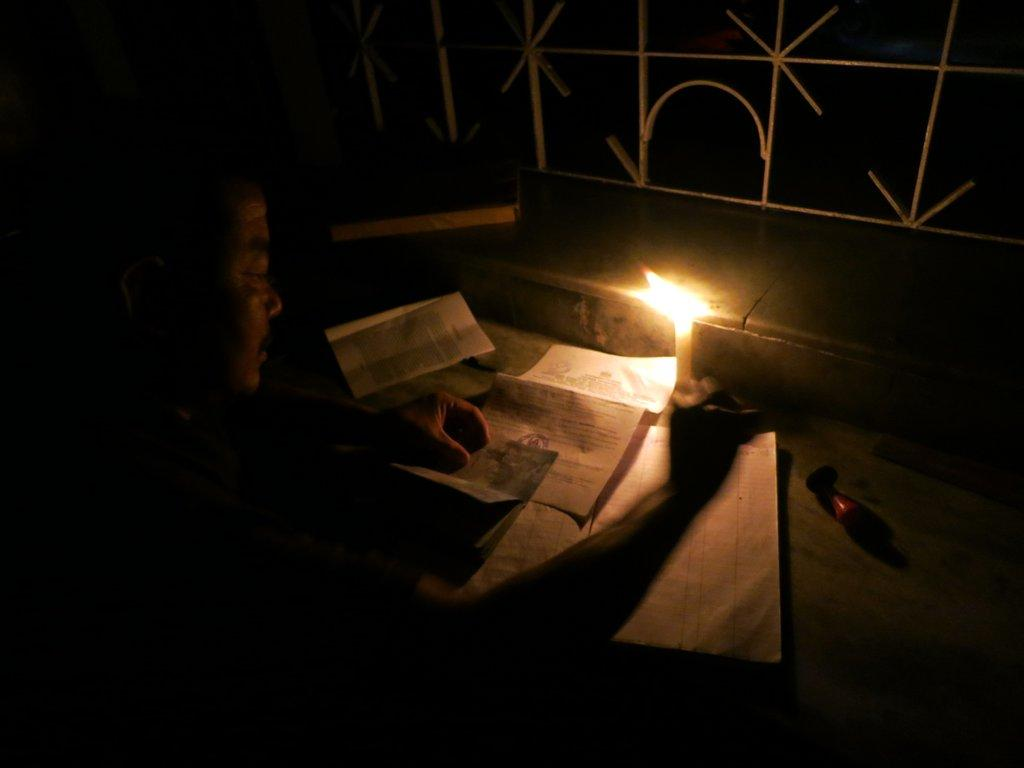What object can be seen in the image that provides light? There is a candle in the image that provides light. What is the man in the image doing? The man is writing with a pen on the paper. What else can be seen in the image besides the candle and the man? There are papers in the image. What type of barrier is present in the image? There is a metal fence in the image. What type of corn can be seen growing near the metal fence in the image? There is no corn present in the image; it only features a candle, papers, a man writing, and a metal fence. What shape is the drug that the man is holding in the image? There is no drug present in the image, and the man is not holding anything. 